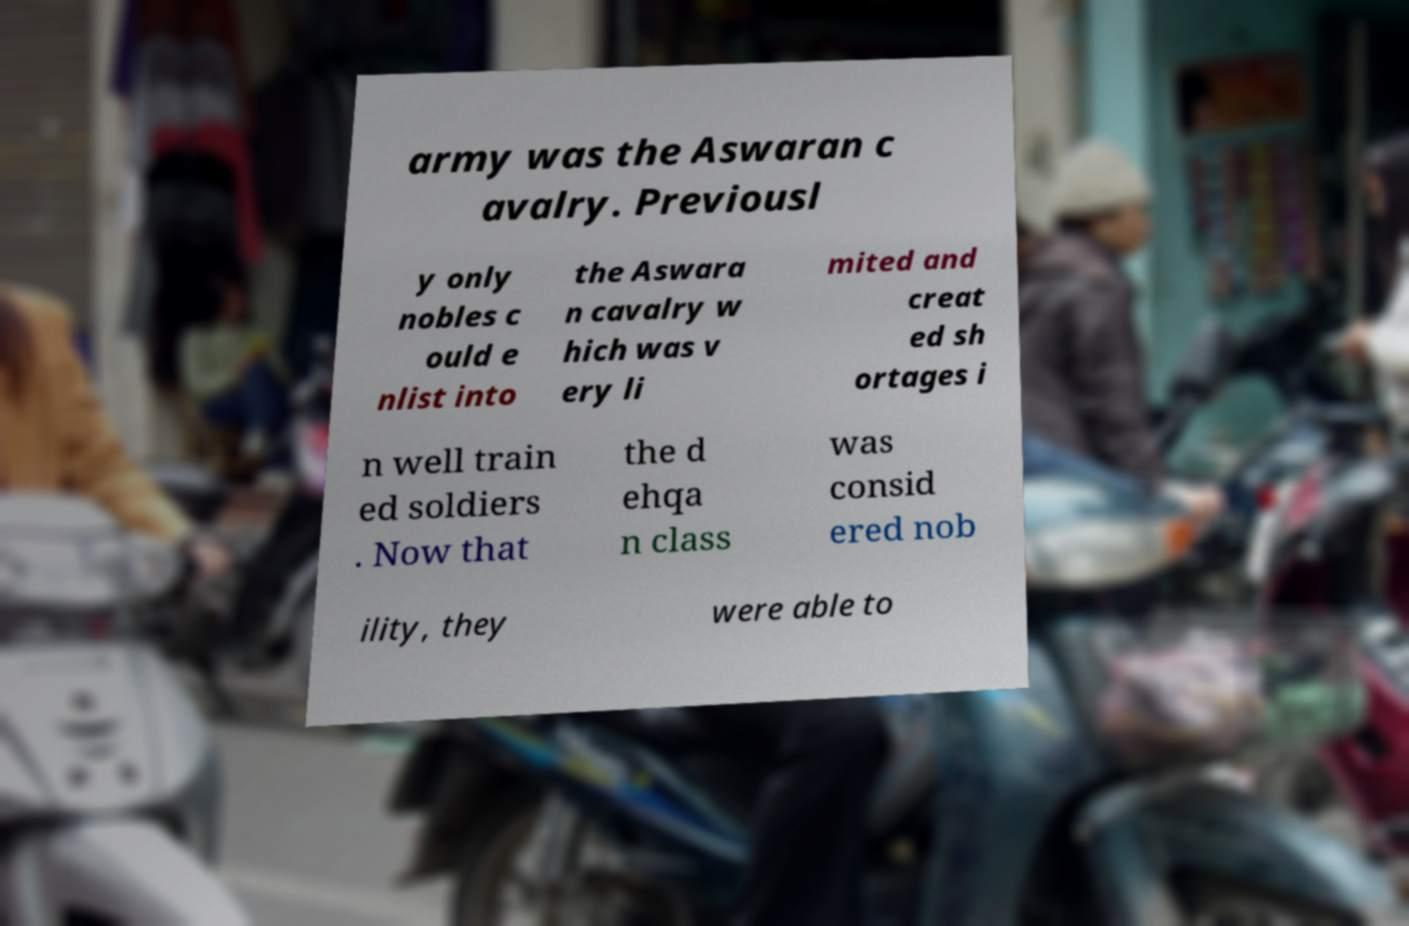Could you extract and type out the text from this image? army was the Aswaran c avalry. Previousl y only nobles c ould e nlist into the Aswara n cavalry w hich was v ery li mited and creat ed sh ortages i n well train ed soldiers . Now that the d ehqa n class was consid ered nob ility, they were able to 